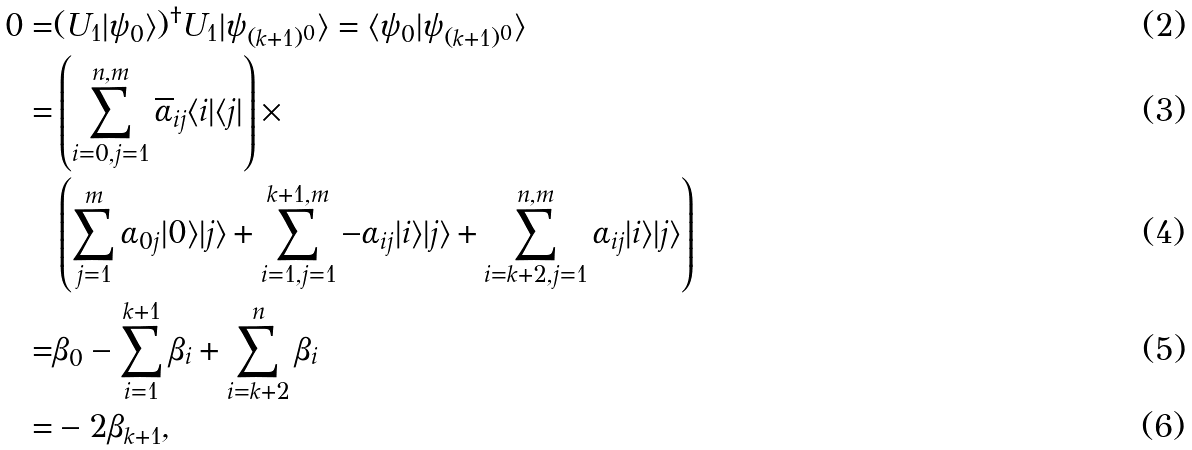Convert formula to latex. <formula><loc_0><loc_0><loc_500><loc_500>0 = & ( U _ { 1 } | \psi _ { 0 } \rangle ) ^ { \dag } U _ { 1 } | \psi _ { ( k + 1 ) ^ { 0 } } \rangle = \langle \psi _ { 0 } | \psi _ { ( k + 1 ) ^ { 0 } } \rangle \\ = & \left ( \sum _ { i = 0 , j = 1 } ^ { n , m } \overline { \alpha } _ { i j } \langle i | \langle j | \right ) \times \\ & \left ( \sum _ { j = 1 } ^ { m } \alpha _ { 0 j } | 0 \rangle | j \rangle + \sum _ { i = 1 , j = 1 } ^ { k + 1 , m } - \alpha _ { i j } | i \rangle | j \rangle + \sum _ { i = k + 2 , j = 1 } ^ { n , m } \alpha _ { i j } | i \rangle | j \rangle \right ) \\ = & \beta _ { 0 } - \sum _ { i = 1 } ^ { k + 1 } \beta _ { i } + \sum _ { i = k + 2 } ^ { n } \beta _ { i } \\ = & - 2 \beta _ { k + 1 } ,</formula> 